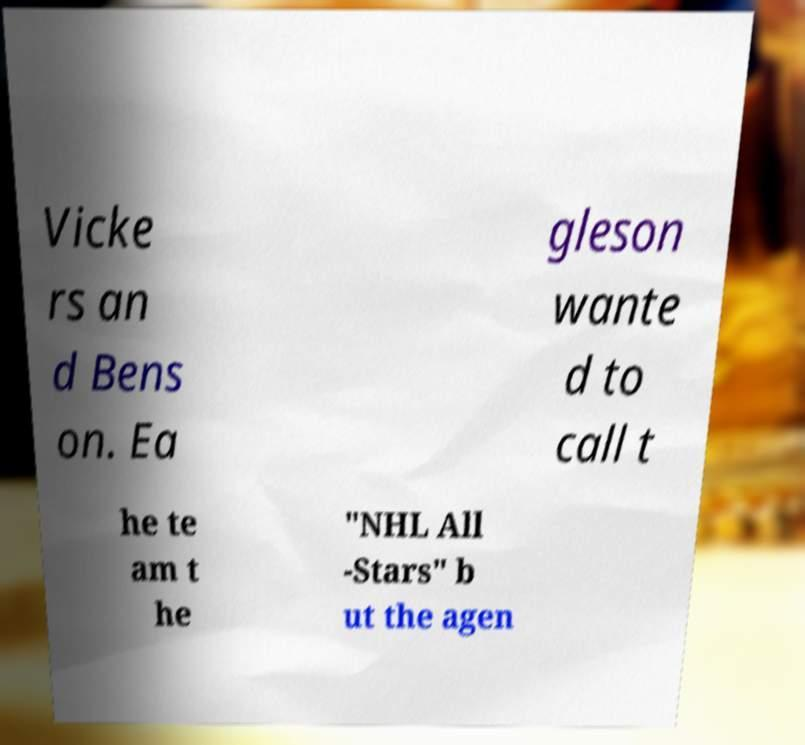Could you extract and type out the text from this image? Vicke rs an d Bens on. Ea gleson wante d to call t he te am t he "NHL All -Stars" b ut the agen 